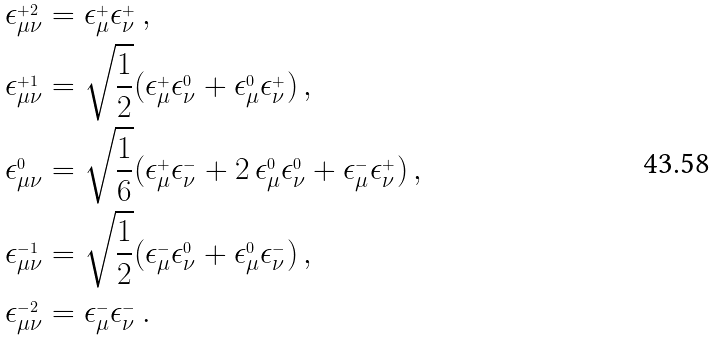Convert formula to latex. <formula><loc_0><loc_0><loc_500><loc_500>\epsilon ^ { _ { + 2 } } _ { \mu \nu } & = \epsilon ^ { _ { + } } _ { \mu } \epsilon ^ { _ { + } } _ { \nu } \, , \\ \epsilon ^ { _ { + 1 } } _ { \mu \nu } & = \sqrt { \frac { 1 } { 2 } } ( \epsilon ^ { _ { + } } _ { \mu } \epsilon ^ { _ { 0 } } _ { \nu } + \epsilon ^ { _ { 0 } } _ { \mu } \epsilon ^ { _ { + } } _ { \nu } ) \, , \\ \epsilon ^ { _ { 0 } } _ { \mu \nu } & = \sqrt { \frac { 1 } { 6 } } ( \epsilon ^ { _ { + } } _ { \mu } \epsilon ^ { _ { - } } _ { \nu } + 2 \, \epsilon ^ { _ { 0 } } _ { \mu } \epsilon ^ { _ { 0 } } _ { \nu } + \epsilon ^ { _ { - } } _ { \mu } \epsilon ^ { _ { + } } _ { \nu } ) \, , \\ \epsilon ^ { _ { - 1 } } _ { \mu \nu } & = \sqrt { \frac { 1 } { 2 } } ( \epsilon ^ { _ { - } } _ { \mu } \epsilon ^ { _ { 0 } } _ { \nu } + \epsilon ^ { _ { 0 } } _ { \mu } \epsilon ^ { _ { - } } _ { \nu } ) \, , \\ \epsilon ^ { _ { - 2 } } _ { \mu \nu } & = \epsilon ^ { _ { - } } _ { \mu } \epsilon ^ { _ { - } } _ { \nu } \, .</formula> 